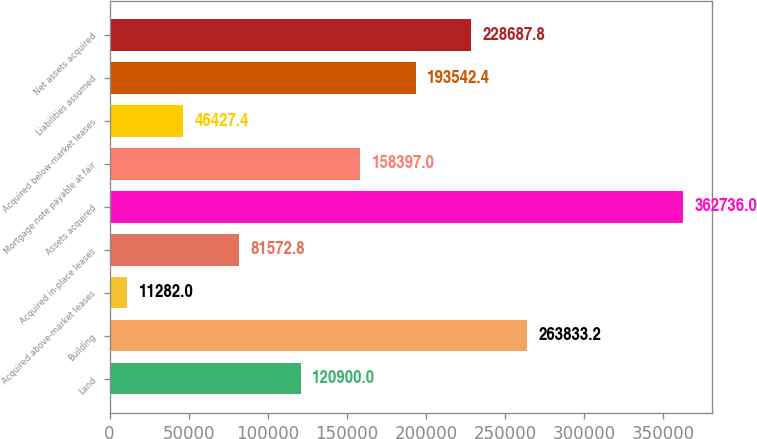Convert chart. <chart><loc_0><loc_0><loc_500><loc_500><bar_chart><fcel>Land<fcel>Building<fcel>Acquired above-market leases<fcel>Acquired in-place leases<fcel>Assets acquired<fcel>Mortgage note payable at fair<fcel>Acquired below-market leases<fcel>Liabilities assumed<fcel>Net assets acquired<nl><fcel>120900<fcel>263833<fcel>11282<fcel>81572.8<fcel>362736<fcel>158397<fcel>46427.4<fcel>193542<fcel>228688<nl></chart> 